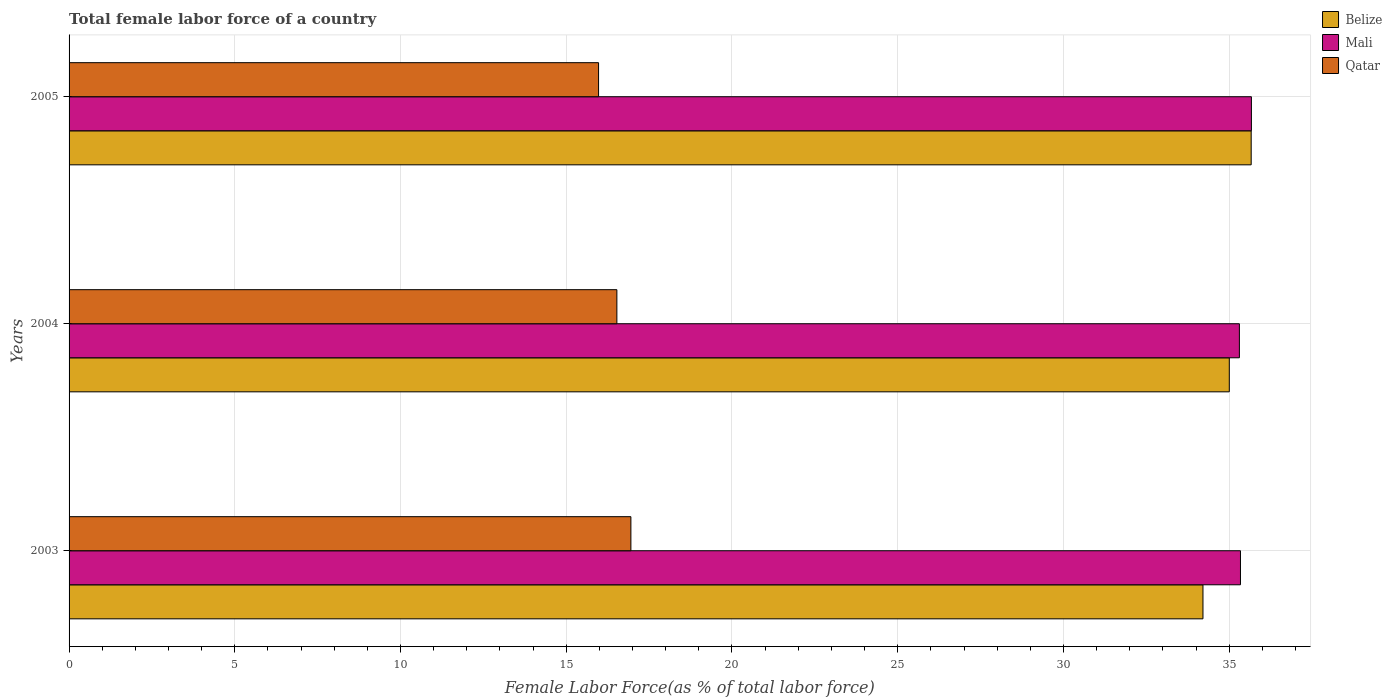How many groups of bars are there?
Give a very brief answer. 3. Are the number of bars per tick equal to the number of legend labels?
Keep it short and to the point. Yes. How many bars are there on the 1st tick from the top?
Ensure brevity in your answer.  3. In how many cases, is the number of bars for a given year not equal to the number of legend labels?
Give a very brief answer. 0. What is the percentage of female labor force in Mali in 2005?
Your answer should be very brief. 35.67. Across all years, what is the maximum percentage of female labor force in Mali?
Your answer should be compact. 35.67. Across all years, what is the minimum percentage of female labor force in Belize?
Provide a short and direct response. 34.21. In which year was the percentage of female labor force in Belize minimum?
Provide a short and direct response. 2003. What is the total percentage of female labor force in Belize in the graph?
Your answer should be compact. 104.88. What is the difference between the percentage of female labor force in Belize in 2004 and that in 2005?
Provide a short and direct response. -0.66. What is the difference between the percentage of female labor force in Mali in 2005 and the percentage of female labor force in Qatar in 2003?
Keep it short and to the point. 18.72. What is the average percentage of female labor force in Mali per year?
Offer a terse response. 35.44. In the year 2004, what is the difference between the percentage of female labor force in Mali and percentage of female labor force in Belize?
Make the answer very short. 0.3. In how many years, is the percentage of female labor force in Belize greater than 25 %?
Ensure brevity in your answer.  3. What is the ratio of the percentage of female labor force in Belize in 2003 to that in 2005?
Your response must be concise. 0.96. What is the difference between the highest and the second highest percentage of female labor force in Belize?
Ensure brevity in your answer.  0.66. What is the difference between the highest and the lowest percentage of female labor force in Belize?
Give a very brief answer. 1.45. Is the sum of the percentage of female labor force in Belize in 2004 and 2005 greater than the maximum percentage of female labor force in Mali across all years?
Offer a very short reply. Yes. What does the 2nd bar from the top in 2004 represents?
Provide a short and direct response. Mali. What does the 1st bar from the bottom in 2004 represents?
Give a very brief answer. Belize. How many years are there in the graph?
Offer a very short reply. 3. What is the difference between two consecutive major ticks on the X-axis?
Make the answer very short. 5. Are the values on the major ticks of X-axis written in scientific E-notation?
Your answer should be very brief. No. Does the graph contain grids?
Your answer should be compact. Yes. Where does the legend appear in the graph?
Ensure brevity in your answer.  Top right. How many legend labels are there?
Your answer should be compact. 3. What is the title of the graph?
Make the answer very short. Total female labor force of a country. What is the label or title of the X-axis?
Give a very brief answer. Female Labor Force(as % of total labor force). What is the Female Labor Force(as % of total labor force) of Belize in 2003?
Ensure brevity in your answer.  34.21. What is the Female Labor Force(as % of total labor force) in Mali in 2003?
Your answer should be compact. 35.34. What is the Female Labor Force(as % of total labor force) in Qatar in 2003?
Your answer should be very brief. 16.95. What is the Female Labor Force(as % of total labor force) of Belize in 2004?
Provide a succinct answer. 35. What is the Female Labor Force(as % of total labor force) of Mali in 2004?
Your response must be concise. 35.31. What is the Female Labor Force(as % of total labor force) of Qatar in 2004?
Your answer should be compact. 16.53. What is the Female Labor Force(as % of total labor force) in Belize in 2005?
Make the answer very short. 35.66. What is the Female Labor Force(as % of total labor force) in Mali in 2005?
Your answer should be compact. 35.67. What is the Female Labor Force(as % of total labor force) in Qatar in 2005?
Give a very brief answer. 15.97. Across all years, what is the maximum Female Labor Force(as % of total labor force) of Belize?
Your response must be concise. 35.66. Across all years, what is the maximum Female Labor Force(as % of total labor force) in Mali?
Your response must be concise. 35.67. Across all years, what is the maximum Female Labor Force(as % of total labor force) of Qatar?
Make the answer very short. 16.95. Across all years, what is the minimum Female Labor Force(as % of total labor force) of Belize?
Ensure brevity in your answer.  34.21. Across all years, what is the minimum Female Labor Force(as % of total labor force) of Mali?
Make the answer very short. 35.31. Across all years, what is the minimum Female Labor Force(as % of total labor force) in Qatar?
Offer a very short reply. 15.97. What is the total Female Labor Force(as % of total labor force) of Belize in the graph?
Offer a terse response. 104.88. What is the total Female Labor Force(as % of total labor force) in Mali in the graph?
Ensure brevity in your answer.  106.32. What is the total Female Labor Force(as % of total labor force) in Qatar in the graph?
Ensure brevity in your answer.  49.45. What is the difference between the Female Labor Force(as % of total labor force) in Belize in 2003 and that in 2004?
Your response must be concise. -0.79. What is the difference between the Female Labor Force(as % of total labor force) of Mali in 2003 and that in 2004?
Give a very brief answer. 0.03. What is the difference between the Female Labor Force(as % of total labor force) of Qatar in 2003 and that in 2004?
Provide a succinct answer. 0.42. What is the difference between the Female Labor Force(as % of total labor force) in Belize in 2003 and that in 2005?
Ensure brevity in your answer.  -1.45. What is the difference between the Female Labor Force(as % of total labor force) in Mali in 2003 and that in 2005?
Give a very brief answer. -0.33. What is the difference between the Female Labor Force(as % of total labor force) of Qatar in 2003 and that in 2005?
Your answer should be very brief. 0.98. What is the difference between the Female Labor Force(as % of total labor force) of Belize in 2004 and that in 2005?
Provide a short and direct response. -0.66. What is the difference between the Female Labor Force(as % of total labor force) in Mali in 2004 and that in 2005?
Make the answer very short. -0.36. What is the difference between the Female Labor Force(as % of total labor force) in Qatar in 2004 and that in 2005?
Keep it short and to the point. 0.55. What is the difference between the Female Labor Force(as % of total labor force) in Belize in 2003 and the Female Labor Force(as % of total labor force) in Mali in 2004?
Your answer should be very brief. -1.1. What is the difference between the Female Labor Force(as % of total labor force) of Belize in 2003 and the Female Labor Force(as % of total labor force) of Qatar in 2004?
Provide a succinct answer. 17.68. What is the difference between the Female Labor Force(as % of total labor force) of Mali in 2003 and the Female Labor Force(as % of total labor force) of Qatar in 2004?
Your answer should be compact. 18.81. What is the difference between the Female Labor Force(as % of total labor force) in Belize in 2003 and the Female Labor Force(as % of total labor force) in Mali in 2005?
Ensure brevity in your answer.  -1.46. What is the difference between the Female Labor Force(as % of total labor force) in Belize in 2003 and the Female Labor Force(as % of total labor force) in Qatar in 2005?
Ensure brevity in your answer.  18.24. What is the difference between the Female Labor Force(as % of total labor force) in Mali in 2003 and the Female Labor Force(as % of total labor force) in Qatar in 2005?
Make the answer very short. 19.37. What is the difference between the Female Labor Force(as % of total labor force) in Belize in 2004 and the Female Labor Force(as % of total labor force) in Mali in 2005?
Your answer should be compact. -0.67. What is the difference between the Female Labor Force(as % of total labor force) in Belize in 2004 and the Female Labor Force(as % of total labor force) in Qatar in 2005?
Your answer should be compact. 19.03. What is the difference between the Female Labor Force(as % of total labor force) of Mali in 2004 and the Female Labor Force(as % of total labor force) of Qatar in 2005?
Ensure brevity in your answer.  19.33. What is the average Female Labor Force(as % of total labor force) of Belize per year?
Your answer should be compact. 34.96. What is the average Female Labor Force(as % of total labor force) of Mali per year?
Keep it short and to the point. 35.44. What is the average Female Labor Force(as % of total labor force) in Qatar per year?
Keep it short and to the point. 16.48. In the year 2003, what is the difference between the Female Labor Force(as % of total labor force) in Belize and Female Labor Force(as % of total labor force) in Mali?
Provide a short and direct response. -1.13. In the year 2003, what is the difference between the Female Labor Force(as % of total labor force) in Belize and Female Labor Force(as % of total labor force) in Qatar?
Your response must be concise. 17.26. In the year 2003, what is the difference between the Female Labor Force(as % of total labor force) of Mali and Female Labor Force(as % of total labor force) of Qatar?
Make the answer very short. 18.39. In the year 2004, what is the difference between the Female Labor Force(as % of total labor force) in Belize and Female Labor Force(as % of total labor force) in Mali?
Give a very brief answer. -0.3. In the year 2004, what is the difference between the Female Labor Force(as % of total labor force) of Belize and Female Labor Force(as % of total labor force) of Qatar?
Give a very brief answer. 18.48. In the year 2004, what is the difference between the Female Labor Force(as % of total labor force) in Mali and Female Labor Force(as % of total labor force) in Qatar?
Give a very brief answer. 18.78. In the year 2005, what is the difference between the Female Labor Force(as % of total labor force) in Belize and Female Labor Force(as % of total labor force) in Mali?
Ensure brevity in your answer.  -0.01. In the year 2005, what is the difference between the Female Labor Force(as % of total labor force) of Belize and Female Labor Force(as % of total labor force) of Qatar?
Make the answer very short. 19.69. In the year 2005, what is the difference between the Female Labor Force(as % of total labor force) in Mali and Female Labor Force(as % of total labor force) in Qatar?
Offer a terse response. 19.7. What is the ratio of the Female Labor Force(as % of total labor force) in Belize in 2003 to that in 2004?
Give a very brief answer. 0.98. What is the ratio of the Female Labor Force(as % of total labor force) in Qatar in 2003 to that in 2004?
Provide a succinct answer. 1.03. What is the ratio of the Female Labor Force(as % of total labor force) of Belize in 2003 to that in 2005?
Ensure brevity in your answer.  0.96. What is the ratio of the Female Labor Force(as % of total labor force) of Mali in 2003 to that in 2005?
Keep it short and to the point. 0.99. What is the ratio of the Female Labor Force(as % of total labor force) of Qatar in 2003 to that in 2005?
Offer a very short reply. 1.06. What is the ratio of the Female Labor Force(as % of total labor force) of Belize in 2004 to that in 2005?
Provide a succinct answer. 0.98. What is the ratio of the Female Labor Force(as % of total labor force) of Qatar in 2004 to that in 2005?
Offer a very short reply. 1.03. What is the difference between the highest and the second highest Female Labor Force(as % of total labor force) in Belize?
Keep it short and to the point. 0.66. What is the difference between the highest and the second highest Female Labor Force(as % of total labor force) in Mali?
Give a very brief answer. 0.33. What is the difference between the highest and the second highest Female Labor Force(as % of total labor force) in Qatar?
Provide a succinct answer. 0.42. What is the difference between the highest and the lowest Female Labor Force(as % of total labor force) in Belize?
Provide a short and direct response. 1.45. What is the difference between the highest and the lowest Female Labor Force(as % of total labor force) of Mali?
Make the answer very short. 0.36. What is the difference between the highest and the lowest Female Labor Force(as % of total labor force) in Qatar?
Provide a short and direct response. 0.98. 